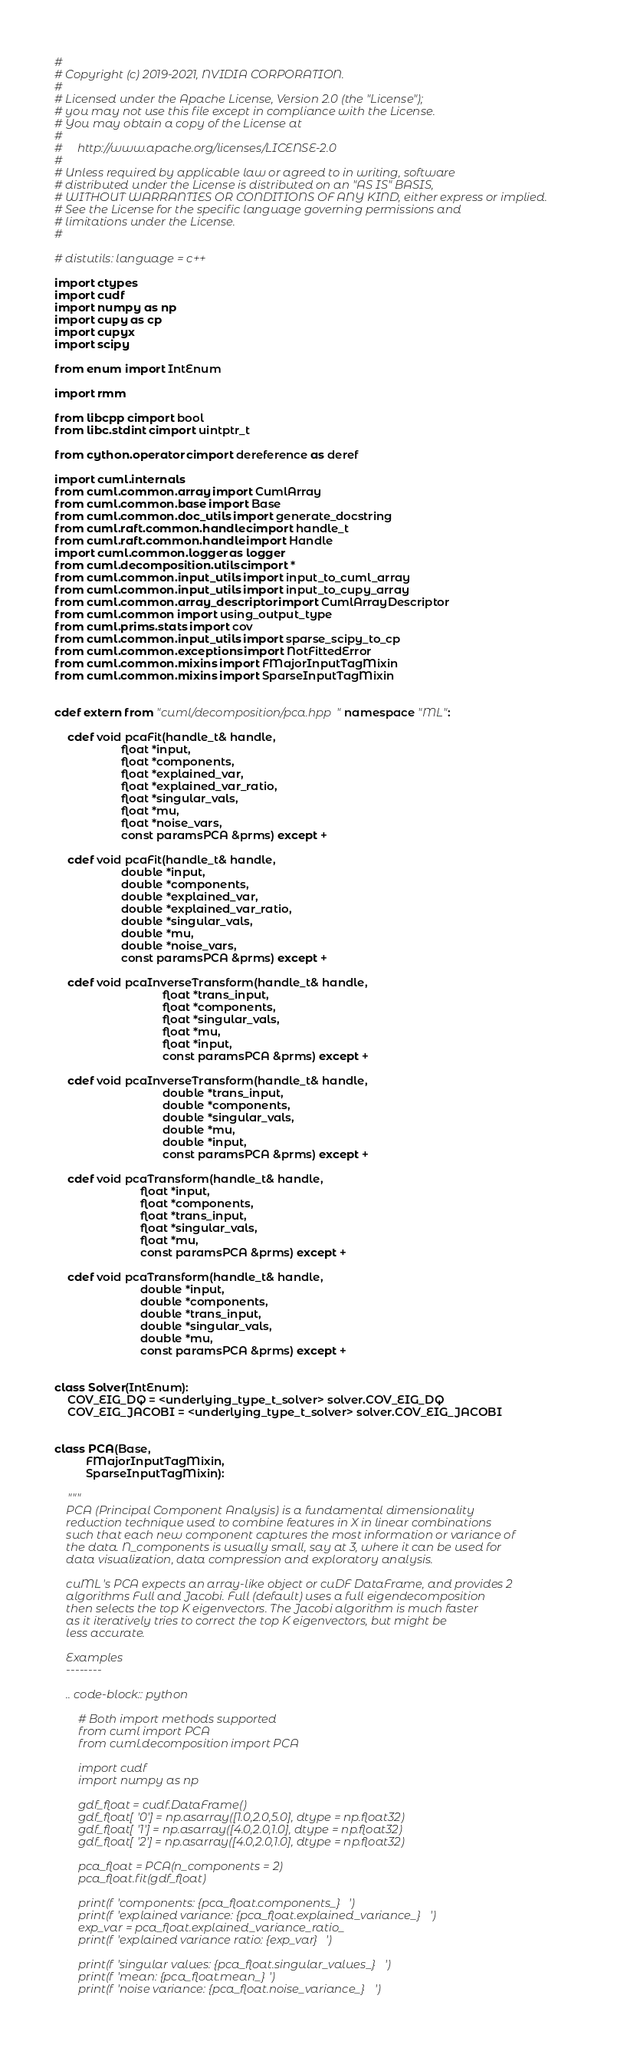Convert code to text. <code><loc_0><loc_0><loc_500><loc_500><_Cython_>#
# Copyright (c) 2019-2021, NVIDIA CORPORATION.
#
# Licensed under the Apache License, Version 2.0 (the "License");
# you may not use this file except in compliance with the License.
# You may obtain a copy of the License at
#
#     http://www.apache.org/licenses/LICENSE-2.0
#
# Unless required by applicable law or agreed to in writing, software
# distributed under the License is distributed on an "AS IS" BASIS,
# WITHOUT WARRANTIES OR CONDITIONS OF ANY KIND, either express or implied.
# See the License for the specific language governing permissions and
# limitations under the License.
#

# distutils: language = c++

import ctypes
import cudf
import numpy as np
import cupy as cp
import cupyx
import scipy

from enum import IntEnum

import rmm

from libcpp cimport bool
from libc.stdint cimport uintptr_t

from cython.operator cimport dereference as deref

import cuml.internals
from cuml.common.array import CumlArray
from cuml.common.base import Base
from cuml.common.doc_utils import generate_docstring
from cuml.raft.common.handle cimport handle_t
from cuml.raft.common.handle import Handle
import cuml.common.logger as logger
from cuml.decomposition.utils cimport *
from cuml.common.input_utils import input_to_cuml_array
from cuml.common.input_utils import input_to_cupy_array
from cuml.common.array_descriptor import CumlArrayDescriptor
from cuml.common import using_output_type
from cuml.prims.stats import cov
from cuml.common.input_utils import sparse_scipy_to_cp
from cuml.common.exceptions import NotFittedError
from cuml.common.mixins import FMajorInputTagMixin
from cuml.common.mixins import SparseInputTagMixin


cdef extern from "cuml/decomposition/pca.hpp" namespace "ML":

    cdef void pcaFit(handle_t& handle,
                     float *input,
                     float *components,
                     float *explained_var,
                     float *explained_var_ratio,
                     float *singular_vals,
                     float *mu,
                     float *noise_vars,
                     const paramsPCA &prms) except +

    cdef void pcaFit(handle_t& handle,
                     double *input,
                     double *components,
                     double *explained_var,
                     double *explained_var_ratio,
                     double *singular_vals,
                     double *mu,
                     double *noise_vars,
                     const paramsPCA &prms) except +

    cdef void pcaInverseTransform(handle_t& handle,
                                  float *trans_input,
                                  float *components,
                                  float *singular_vals,
                                  float *mu,
                                  float *input,
                                  const paramsPCA &prms) except +

    cdef void pcaInverseTransform(handle_t& handle,
                                  double *trans_input,
                                  double *components,
                                  double *singular_vals,
                                  double *mu,
                                  double *input,
                                  const paramsPCA &prms) except +

    cdef void pcaTransform(handle_t& handle,
                           float *input,
                           float *components,
                           float *trans_input,
                           float *singular_vals,
                           float *mu,
                           const paramsPCA &prms) except +

    cdef void pcaTransform(handle_t& handle,
                           double *input,
                           double *components,
                           double *trans_input,
                           double *singular_vals,
                           double *mu,
                           const paramsPCA &prms) except +


class Solver(IntEnum):
    COV_EIG_DQ = <underlying_type_t_solver> solver.COV_EIG_DQ
    COV_EIG_JACOBI = <underlying_type_t_solver> solver.COV_EIG_JACOBI


class PCA(Base,
          FMajorInputTagMixin,
          SparseInputTagMixin):

    """
    PCA (Principal Component Analysis) is a fundamental dimensionality
    reduction technique used to combine features in X in linear combinations
    such that each new component captures the most information or variance of
    the data. N_components is usually small, say at 3, where it can be used for
    data visualization, data compression and exploratory analysis.

    cuML's PCA expects an array-like object or cuDF DataFrame, and provides 2
    algorithms Full and Jacobi. Full (default) uses a full eigendecomposition
    then selects the top K eigenvectors. The Jacobi algorithm is much faster
    as it iteratively tries to correct the top K eigenvectors, but might be
    less accurate.

    Examples
    --------

    .. code-block:: python

        # Both import methods supported
        from cuml import PCA
        from cuml.decomposition import PCA

        import cudf
        import numpy as np

        gdf_float = cudf.DataFrame()
        gdf_float['0'] = np.asarray([1.0,2.0,5.0], dtype = np.float32)
        gdf_float['1'] = np.asarray([4.0,2.0,1.0], dtype = np.float32)
        gdf_float['2'] = np.asarray([4.0,2.0,1.0], dtype = np.float32)

        pca_float = PCA(n_components = 2)
        pca_float.fit(gdf_float)

        print(f'components: {pca_float.components_}')
        print(f'explained variance: {pca_float.explained_variance_}')
        exp_var = pca_float.explained_variance_ratio_
        print(f'explained variance ratio: {exp_var}')

        print(f'singular values: {pca_float.singular_values_}')
        print(f'mean: {pca_float.mean_}')
        print(f'noise variance: {pca_float.noise_variance_}')
</code> 